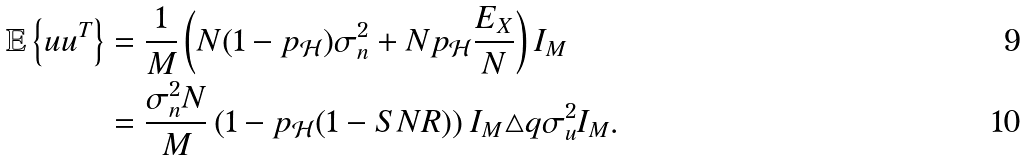<formula> <loc_0><loc_0><loc_500><loc_500>\mathbb { E } \left \{ u u ^ { T } \right \} & = \frac { 1 } { M } \left ( N ( 1 - p _ { \mathcal { H } } ) \sigma _ { n } ^ { 2 } + N p _ { \mathcal { H } } \frac { E _ { X } } { N } \right ) I _ { M } \\ & = \frac { \sigma _ { n } ^ { 2 } N } { M } \left ( 1 - p _ { \mathcal { H } } ( 1 - S N R ) \right ) I _ { M } \triangle q \sigma _ { u } ^ { 2 } I _ { M } .</formula> 